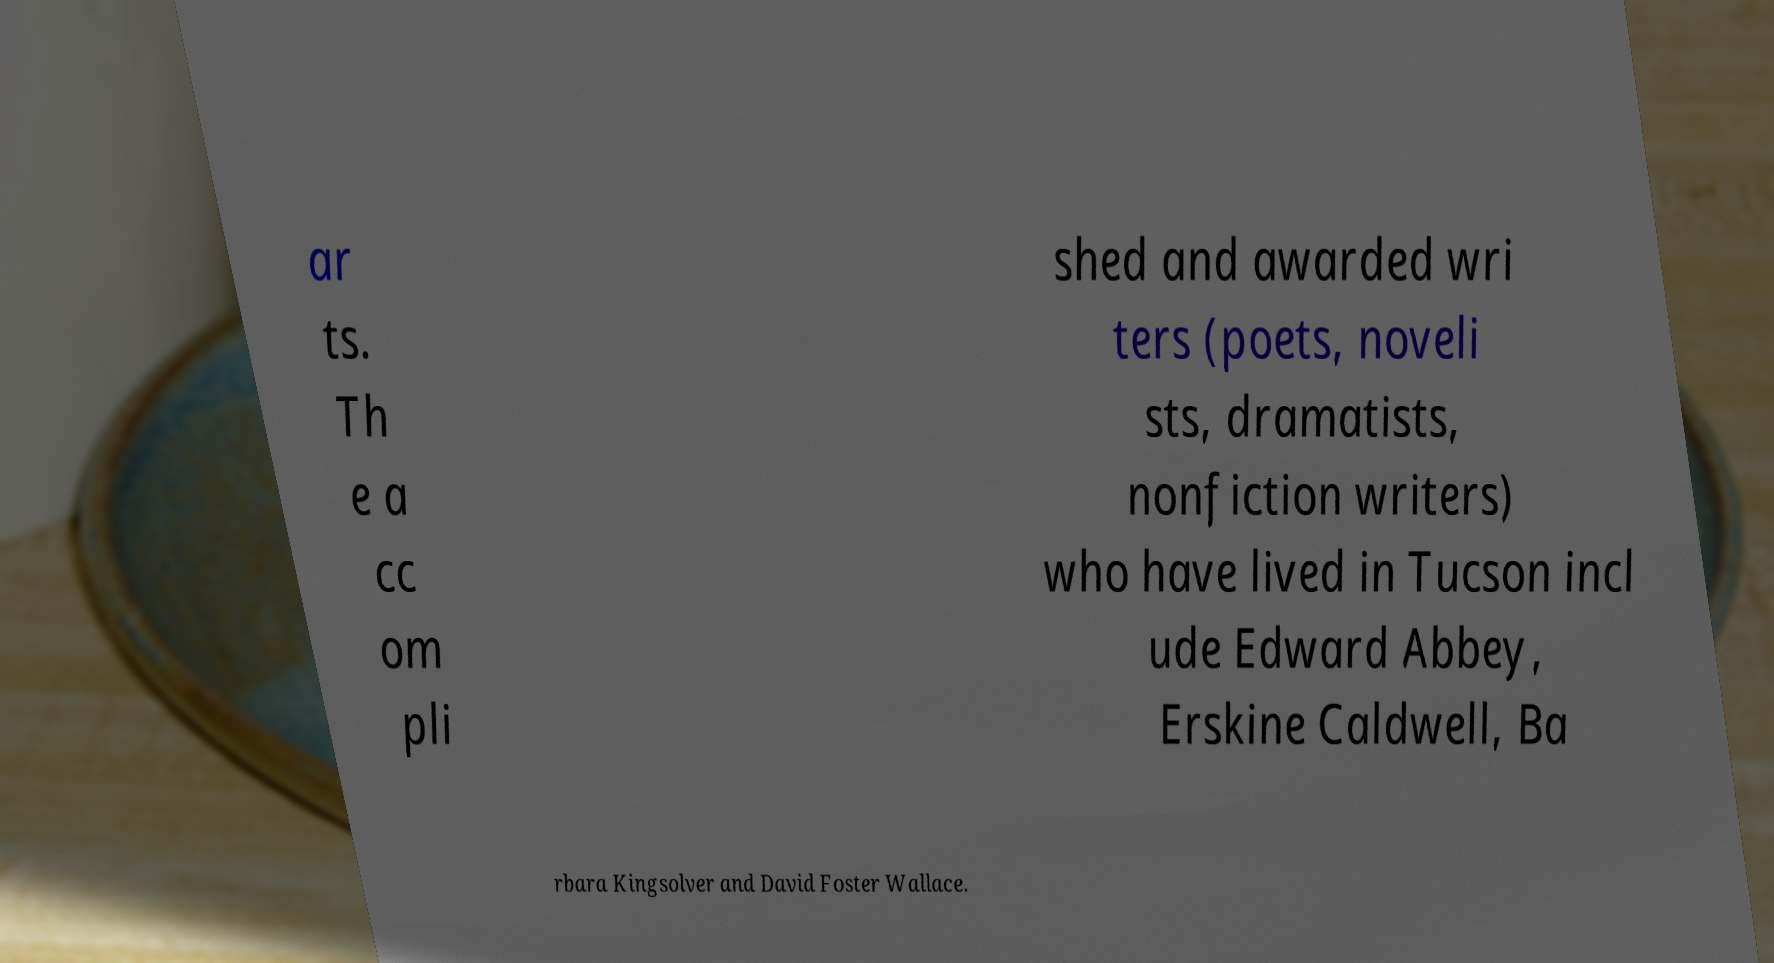Could you extract and type out the text from this image? ar ts. Th e a cc om pli shed and awarded wri ters (poets, noveli sts, dramatists, nonfiction writers) who have lived in Tucson incl ude Edward Abbey, Erskine Caldwell, Ba rbara Kingsolver and David Foster Wallace. 